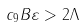<formula> <loc_0><loc_0><loc_500><loc_500>c _ { 9 } B \varepsilon > 2 \Lambda</formula> 